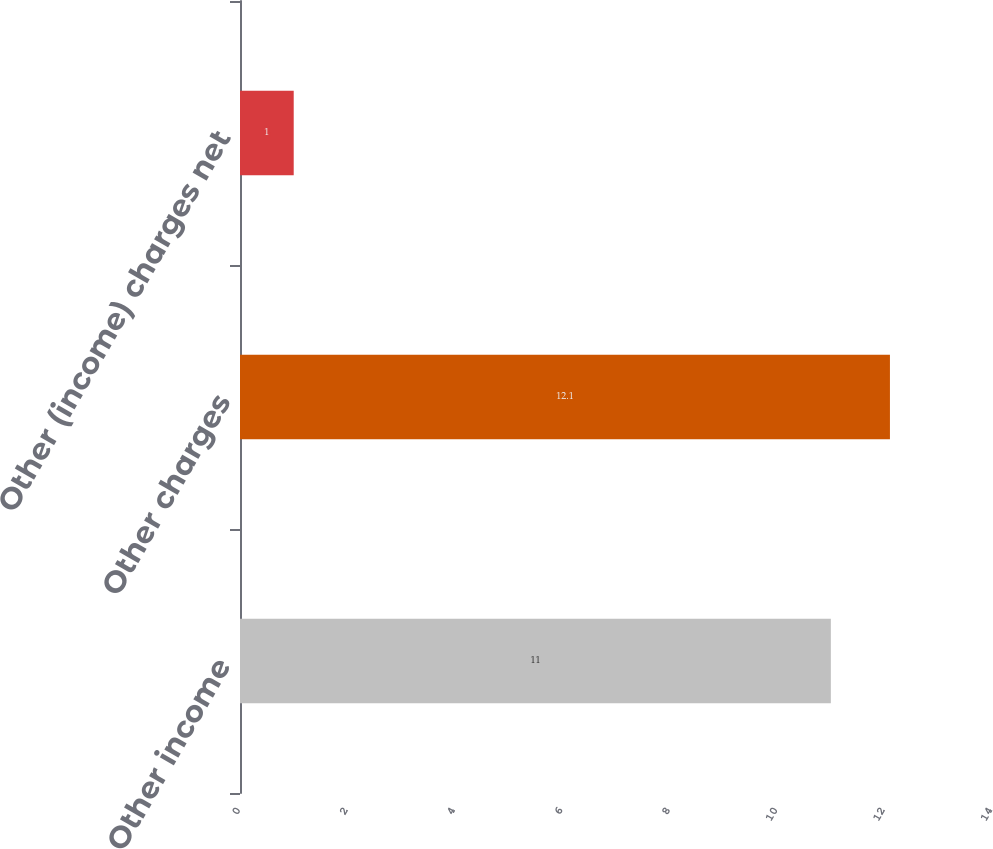<chart> <loc_0><loc_0><loc_500><loc_500><bar_chart><fcel>Other income<fcel>Other charges<fcel>Other (income) charges net<nl><fcel>11<fcel>12.1<fcel>1<nl></chart> 